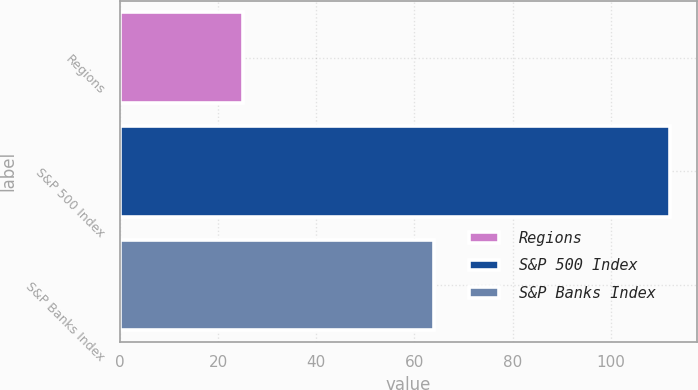Convert chart to OTSL. <chart><loc_0><loc_0><loc_500><loc_500><bar_chart><fcel>Regions<fcel>S&P 500 Index<fcel>S&P Banks Index<nl><fcel>25.07<fcel>111.99<fcel>63.96<nl></chart> 